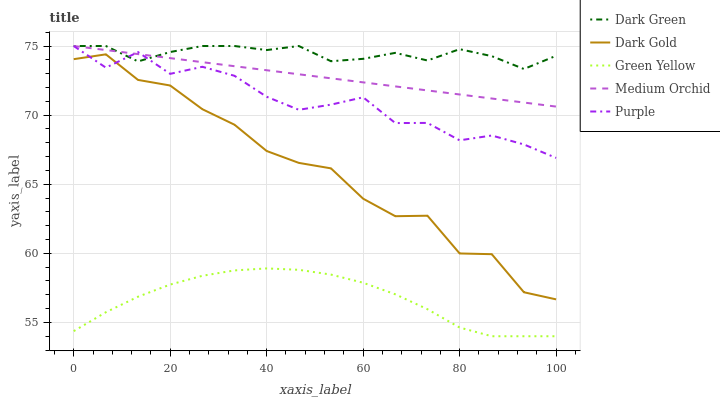Does Green Yellow have the minimum area under the curve?
Answer yes or no. Yes. Does Dark Green have the maximum area under the curve?
Answer yes or no. Yes. Does Dark Gold have the minimum area under the curve?
Answer yes or no. No. Does Dark Gold have the maximum area under the curve?
Answer yes or no. No. Is Medium Orchid the smoothest?
Answer yes or no. Yes. Is Dark Gold the roughest?
Answer yes or no. Yes. Is Green Yellow the smoothest?
Answer yes or no. No. Is Green Yellow the roughest?
Answer yes or no. No. Does Green Yellow have the lowest value?
Answer yes or no. Yes. Does Dark Gold have the lowest value?
Answer yes or no. No. Does Dark Green have the highest value?
Answer yes or no. Yes. Does Dark Gold have the highest value?
Answer yes or no. No. Is Dark Gold less than Medium Orchid?
Answer yes or no. Yes. Is Dark Green greater than Dark Gold?
Answer yes or no. Yes. Does Dark Green intersect Medium Orchid?
Answer yes or no. Yes. Is Dark Green less than Medium Orchid?
Answer yes or no. No. Is Dark Green greater than Medium Orchid?
Answer yes or no. No. Does Dark Gold intersect Medium Orchid?
Answer yes or no. No. 